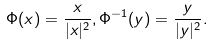Convert formula to latex. <formula><loc_0><loc_0><loc_500><loc_500>\Phi ( x ) = \frac { x } { | x | ^ { 2 } } , \Phi ^ { - 1 } ( y ) = \frac { y } { | y | ^ { 2 } } .</formula> 